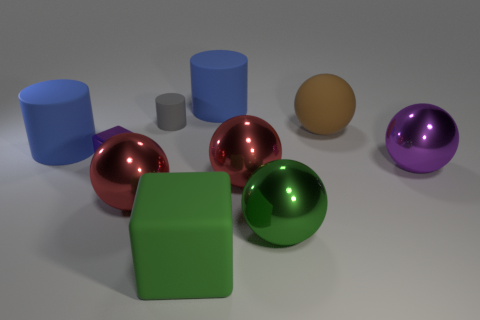Are there the same number of large metallic objects that are on the right side of the green ball and big brown things? Yes, there are an equal number of large metallic objects on the right side of the green ball as there are big brown objects, which is two of each kind. 